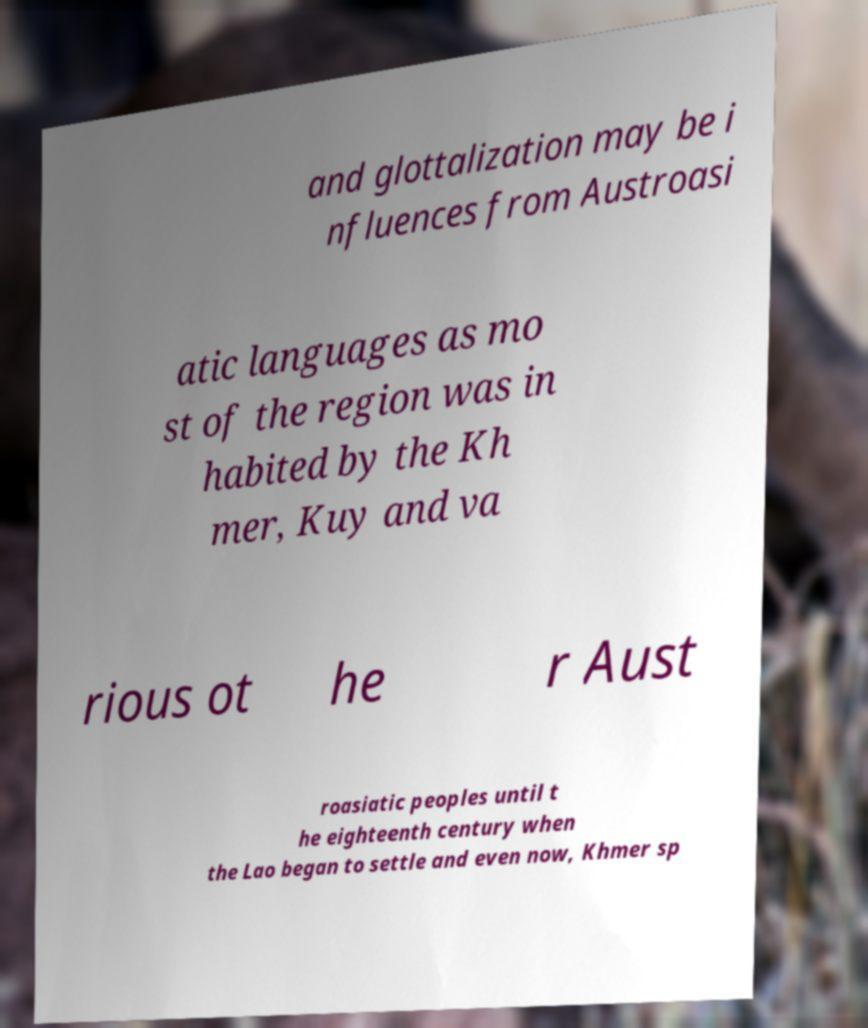Could you assist in decoding the text presented in this image and type it out clearly? and glottalization may be i nfluences from Austroasi atic languages as mo st of the region was in habited by the Kh mer, Kuy and va rious ot he r Aust roasiatic peoples until t he eighteenth century when the Lao began to settle and even now, Khmer sp 